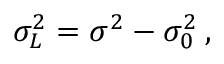Convert formula to latex. <formula><loc_0><loc_0><loc_500><loc_500>\sigma _ { L } ^ { 2 } = \sigma ^ { 2 } - \sigma _ { 0 } ^ { 2 } \, ,</formula> 